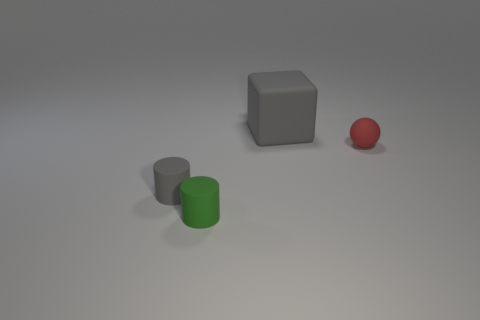Add 4 tiny purple metallic objects. How many objects exist? 8 Subtract all balls. How many objects are left? 3 Subtract all tiny green metallic cubes. Subtract all small green cylinders. How many objects are left? 3 Add 4 small gray matte cylinders. How many small gray matte cylinders are left? 5 Add 3 red things. How many red things exist? 4 Subtract 0 yellow cylinders. How many objects are left? 4 